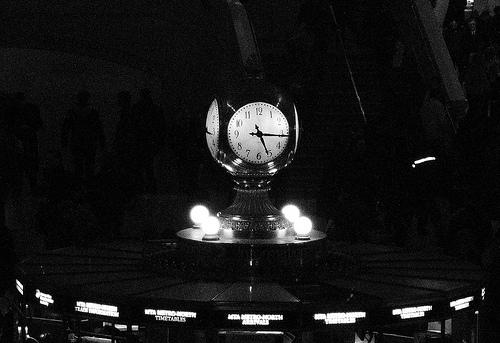Question: what time is it?
Choices:
A. 5:15.
B. 5:30.
C. 6:00.
D. 2:00.
Answer with the letter. Answer: A Question: how many light bulbs under the clock?
Choices:
A. Five.
B. One.
C. Four.
D. Six.
Answer with the letter. Answer: C Question: how many hands does the clock have?
Choices:
A. Two.
B. One.
C. Three.
D. Four.
Answer with the letter. Answer: A Question: why is there a clock?
Choices:
A. Decoration.
B. To keep a schedule.
C. To tell time.
D. To make white noise.
Answer with the letter. Answer: C Question: how many faces does the clock have?
Choices:
A. Four.
B. Two.
C. One.
D. Three.
Answer with the letter. Answer: A Question: what color are the hands of the clock?
Choices:
A. Bronze.
B. White.
C. Blue.
D. Black.
Answer with the letter. Answer: D 